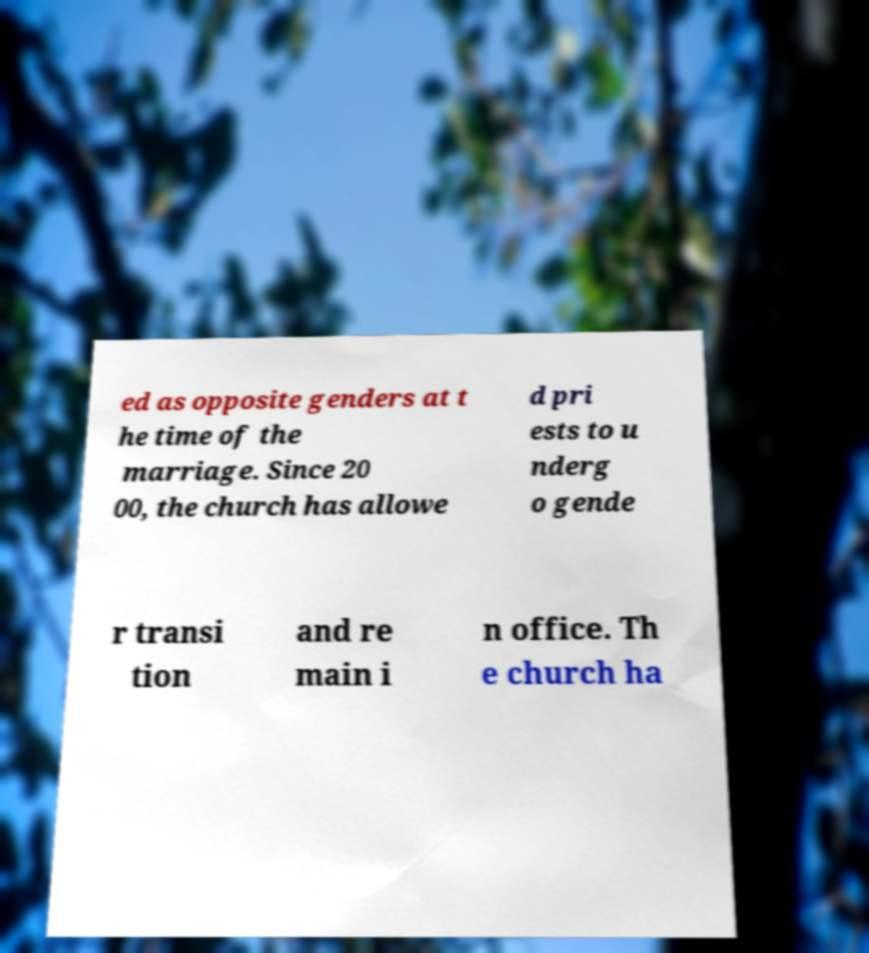There's text embedded in this image that I need extracted. Can you transcribe it verbatim? ed as opposite genders at t he time of the marriage. Since 20 00, the church has allowe d pri ests to u nderg o gende r transi tion and re main i n office. Th e church ha 